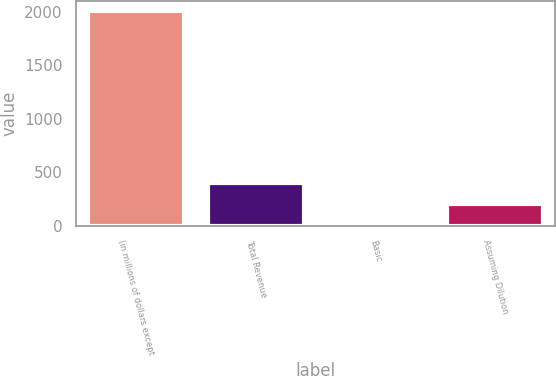Convert chart. <chart><loc_0><loc_0><loc_500><loc_500><bar_chart><fcel>(in millions of dollars except<fcel>Total Revenue<fcel>Basic<fcel>Assuming Dilution<nl><fcel>2006<fcel>401.22<fcel>0.02<fcel>200.62<nl></chart> 